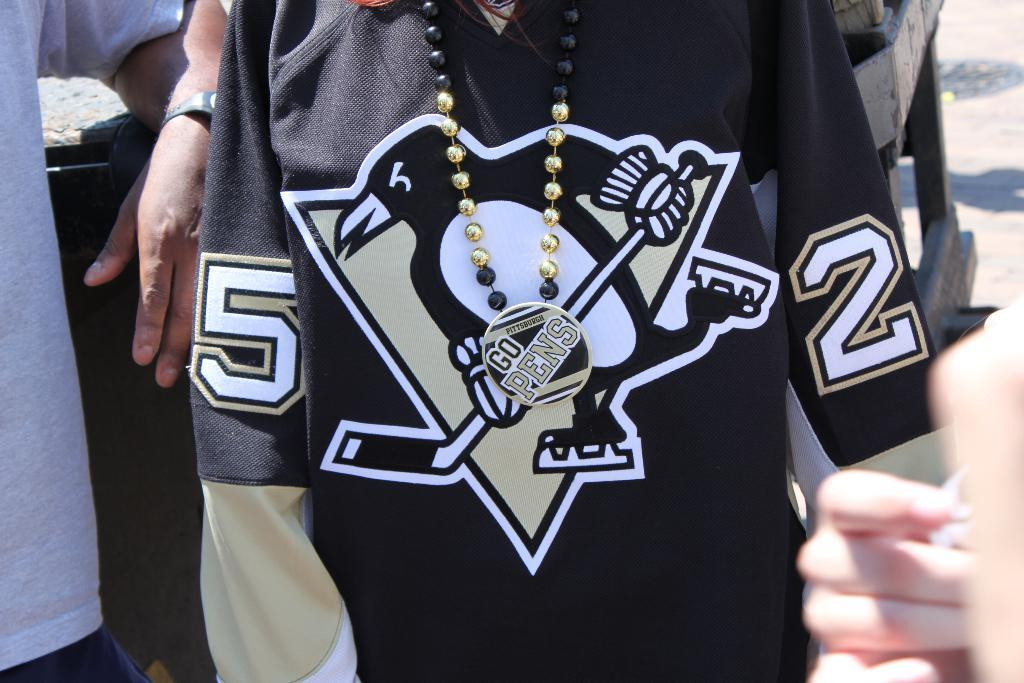<image>
Give a short and clear explanation of the subsequent image. man wearing a hockey jersey for the team penguins numbered 52. 